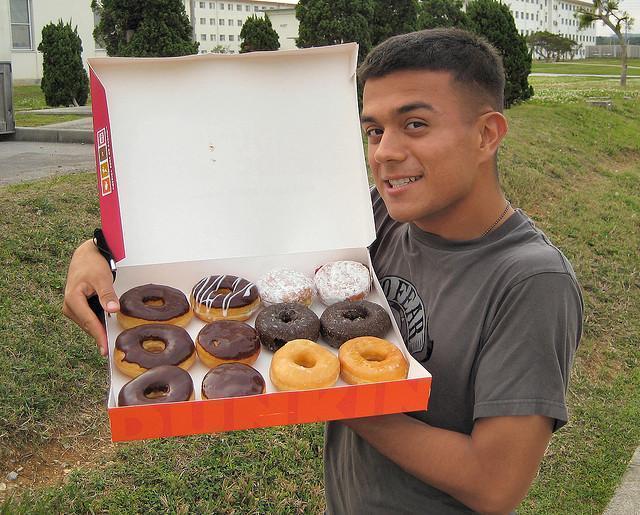What morning beverage is this company famous for?
Answer the question by selecting the correct answer among the 4 following choices and explain your choice with a short sentence. The answer should be formatted with the following format: `Answer: choice
Rationale: rationale.`
Options: Oatmeal, lemonade, coffee, fruit punch. Answer: coffee.
Rationale: You eat donuts with coffee. 